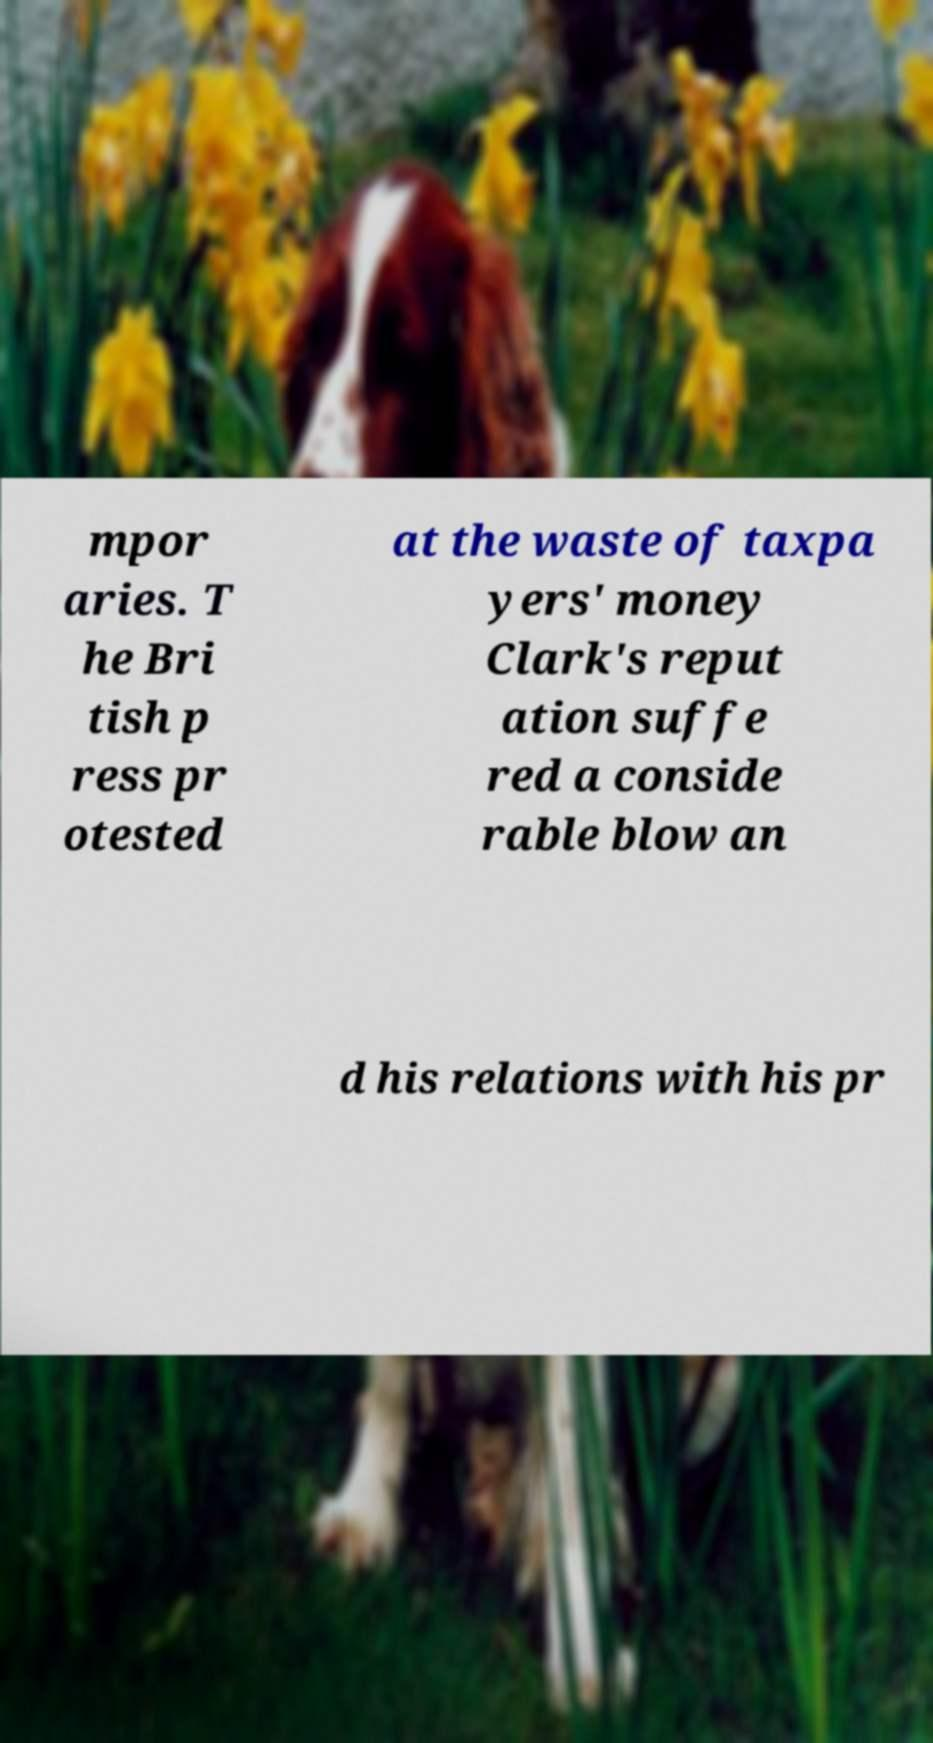Please identify and transcribe the text found in this image. mpor aries. T he Bri tish p ress pr otested at the waste of taxpa yers' money Clark's reput ation suffe red a conside rable blow an d his relations with his pr 